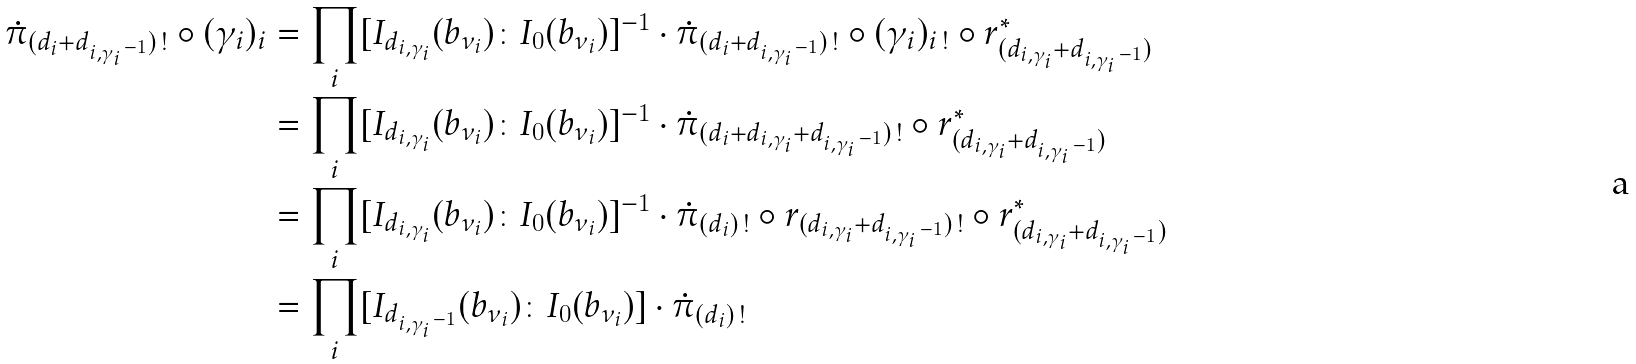Convert formula to latex. <formula><loc_0><loc_0><loc_500><loc_500>\dot { \pi } _ { ( d _ { i } + d _ { i , \gamma _ { i } { } ^ { \, - 1 } } ) \, ! } \circ ( \gamma _ { i } ) _ { i } & = \prod _ { i } [ I _ { d _ { i , \gamma _ { i } } } ( b _ { \nu _ { i } } ) \colon I _ { 0 } ( b _ { \nu _ { i } } ) ] ^ { - 1 } \cdot \dot { \pi } _ { ( d _ { i } + d _ { i , \gamma _ { i } { } ^ { \, - 1 } } ) \, ! } \circ ( \gamma _ { i } ) _ { i \, ! } \circ r _ { ( d _ { i , \gamma _ { i } } + d _ { i , \gamma _ { i } { } ^ { \, - 1 } } ) } ^ { * } \\ & = \prod _ { i } [ I _ { d _ { i , \gamma _ { i } } } ( b _ { \nu _ { i } } ) \colon I _ { 0 } ( b _ { \nu _ { i } } ) ] ^ { - 1 } \cdot \dot { \pi } _ { ( d _ { i } + d _ { i , \gamma _ { i } } + d _ { i , \gamma _ { i } { } ^ { \, - 1 } } ) \, ! } \circ r _ { ( d _ { i , \gamma _ { i } } + d _ { i , \gamma _ { i } { } ^ { \, - 1 } } ) } ^ { * } \\ & = \prod _ { i } [ I _ { d _ { i , \gamma _ { i } } } ( b _ { \nu _ { i } } ) \colon I _ { 0 } ( b _ { \nu _ { i } } ) ] ^ { - 1 } \cdot \dot { \pi } _ { ( d _ { i } ) \, ! } \circ r _ { ( d _ { i , \gamma _ { i } } + d _ { i , \gamma _ { i } { } ^ { \, - 1 } } ) \, ! } \circ r _ { ( d _ { i , \gamma _ { i } } + d _ { i , \gamma _ { i } { } ^ { \, - 1 } } ) } ^ { * } \\ & = \prod _ { i } [ I _ { d _ { i , \gamma _ { i } { } ^ { \, - 1 } } } ( b _ { \nu _ { i } } ) \colon I _ { 0 } ( b _ { \nu _ { i } } ) ] \cdot \dot { \pi } _ { ( d _ { i } ) \, ! }</formula> 